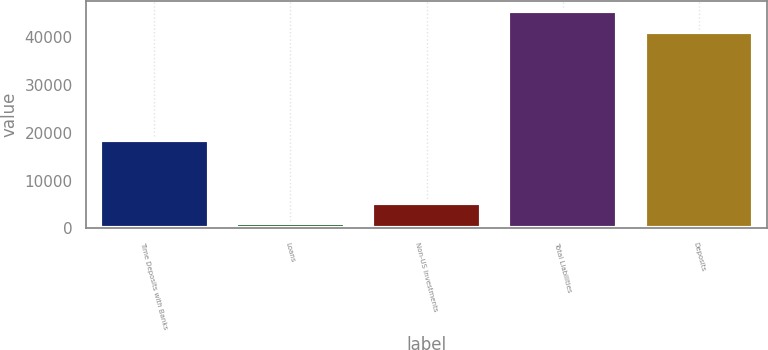Convert chart to OTSL. <chart><loc_0><loc_0><loc_500><loc_500><bar_chart><fcel>Time Deposits with Banks<fcel>Loans<fcel>Non-US Investments<fcel>Total Liabilities<fcel>Deposits<nl><fcel>18580.4<fcel>1091.1<fcel>5325.66<fcel>45395.5<fcel>41160.9<nl></chart> 